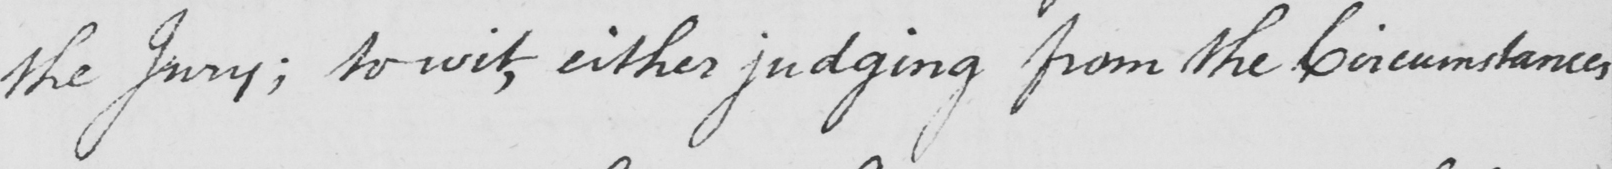Please transcribe the handwritten text in this image. the Jury ; to wit , either judging from the Circumstances 